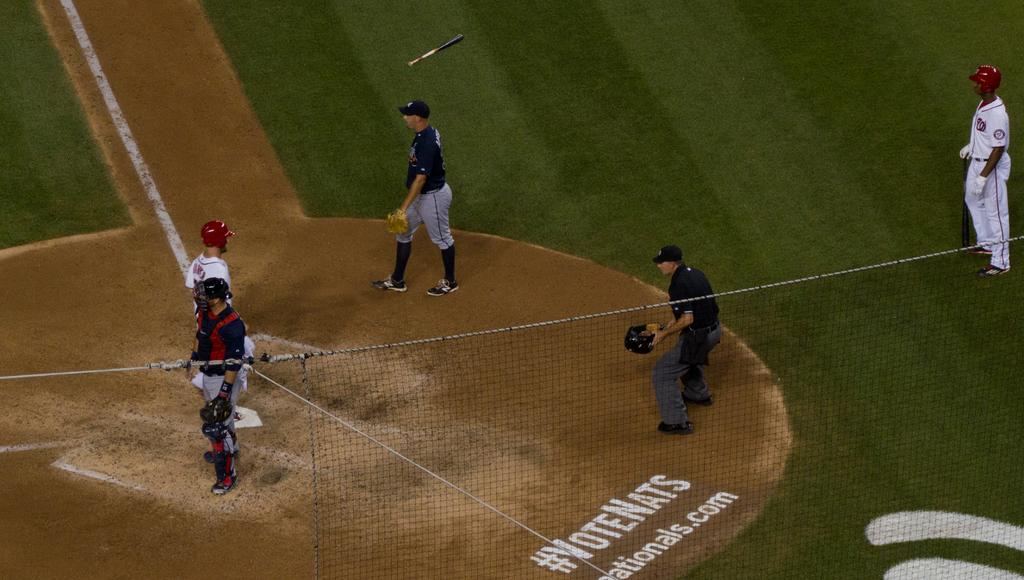<image>
Provide a brief description of the given image. VoteNats can be seen painted in white on a baseball diamond. 